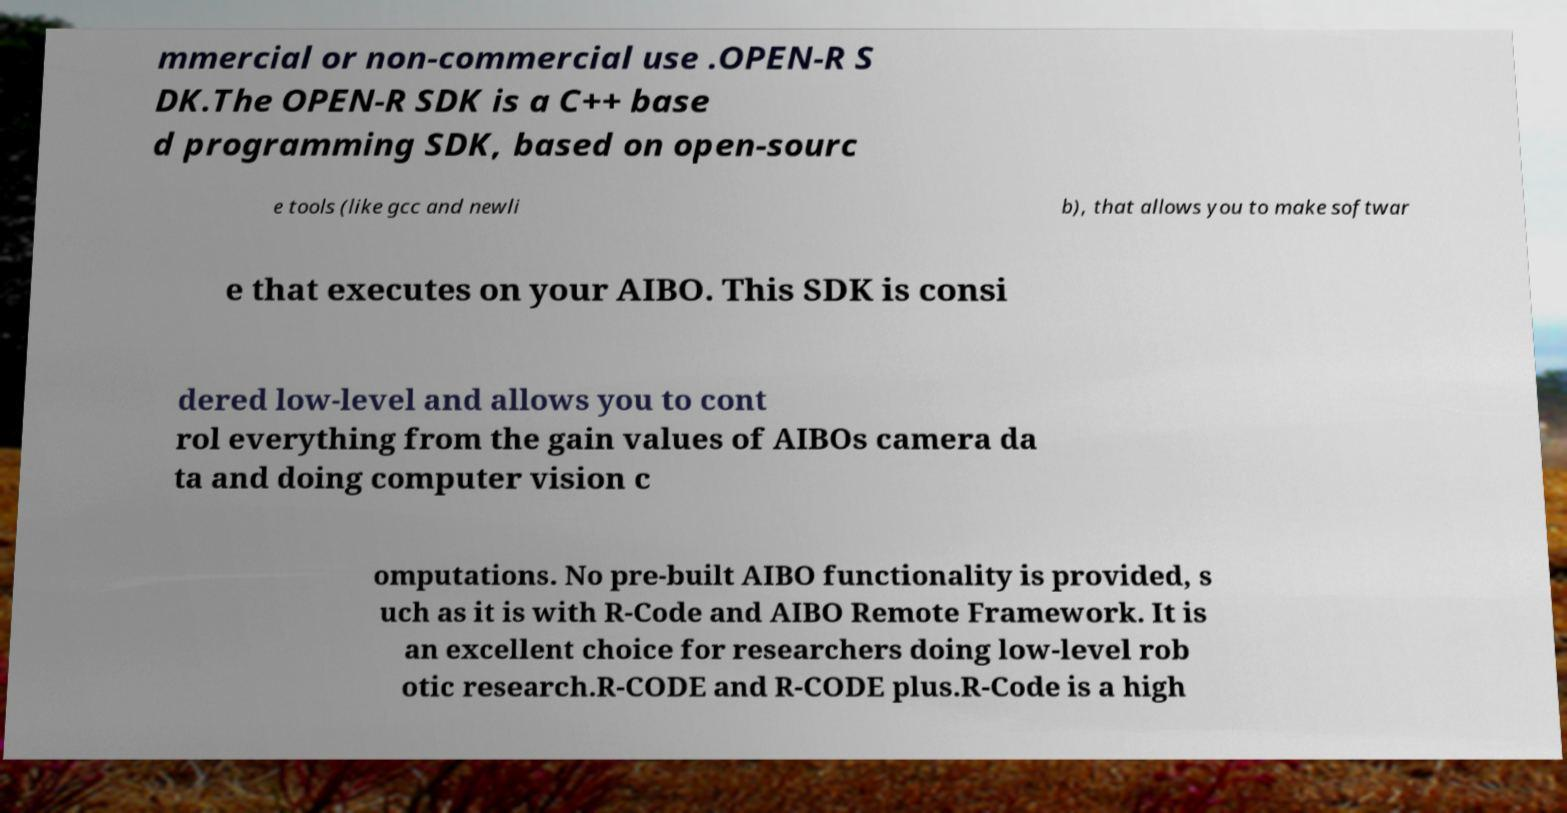I need the written content from this picture converted into text. Can you do that? mmercial or non-commercial use .OPEN-R S DK.The OPEN-R SDK is a C++ base d programming SDK, based on open-sourc e tools (like gcc and newli b), that allows you to make softwar e that executes on your AIBO. This SDK is consi dered low-level and allows you to cont rol everything from the gain values of AIBOs camera da ta and doing computer vision c omputations. No pre-built AIBO functionality is provided, s uch as it is with R-Code and AIBO Remote Framework. It is an excellent choice for researchers doing low-level rob otic research.R-CODE and R-CODE plus.R-Code is a high 